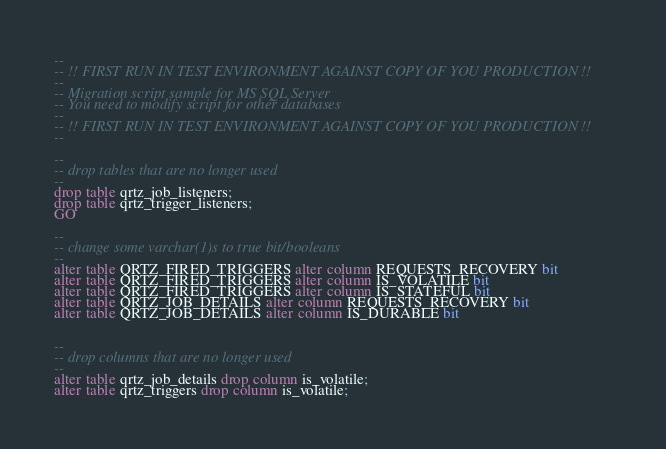Convert code to text. <code><loc_0><loc_0><loc_500><loc_500><_SQL_>--
-- !! FIRST RUN IN TEST ENVIRONMENT AGAINST COPY OF YOU PRODUCTION !!
--
-- Migration script sample for MS SQL Server
-- You need to modify script for other databases
--
-- !! FIRST RUN IN TEST ENVIRONMENT AGAINST COPY OF YOU PRODUCTION !!
--

-- 
-- drop tables that are no longer used
--
drop table qrtz_job_listeners;
drop table qrtz_trigger_listeners;
GO

--
-- change some varchar(1)s to true bit/booleans
--
alter table QRTZ_FIRED_TRIGGERS alter column REQUESTS_RECOVERY bit
alter table QRTZ_FIRED_TRIGGERS alter column IS_VOLATILE bit
alter table QRTZ_FIRED_TRIGGERS alter column IS_STATEFUL bit
alter table QRTZ_JOB_DETAILS alter column REQUESTS_RECOVERY bit
alter table QRTZ_JOB_DETAILS alter column IS_DURABLE bit


--
-- drop columns that are no longer used
--
alter table qrtz_job_details drop column is_volatile;
alter table qrtz_triggers drop column is_volatile;</code> 